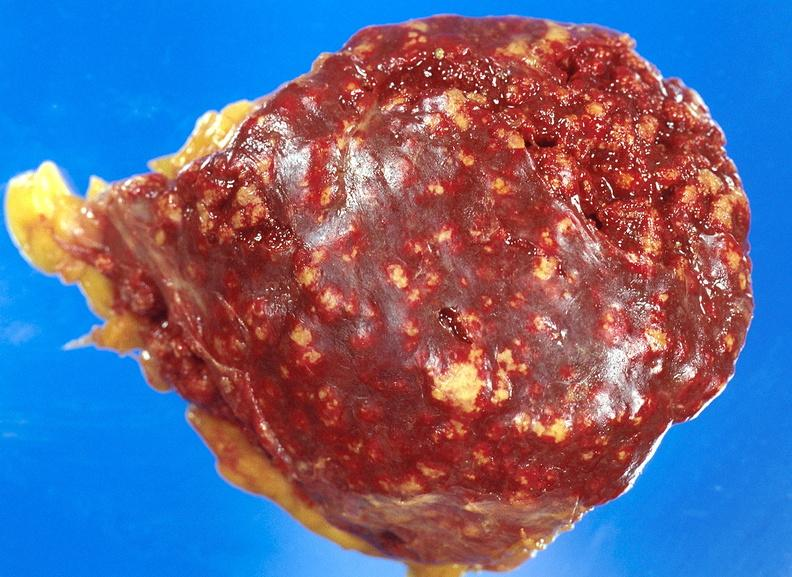does maxillary sinus show spleen, tuberculosis?
Answer the question using a single word or phrase. No 